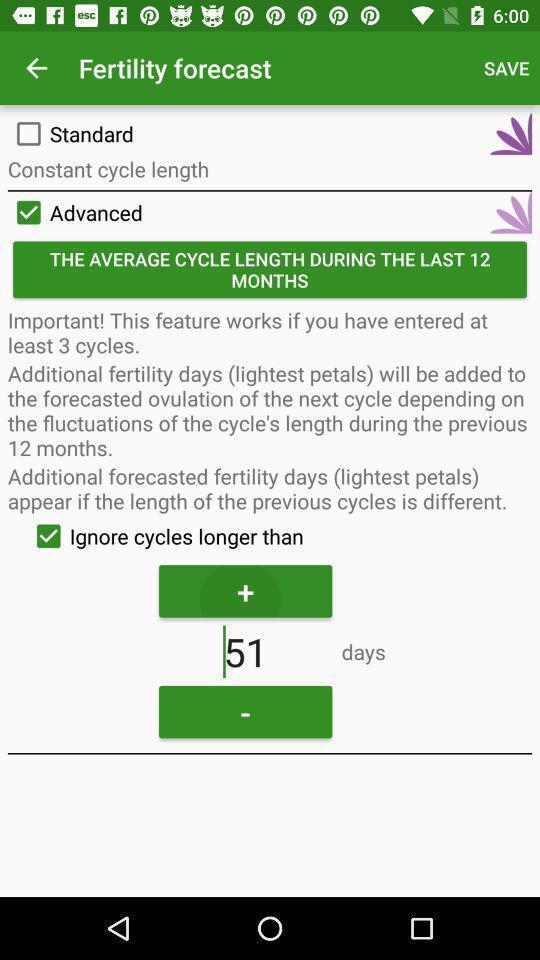Explain what's happening in this screen capture. Screen display fertility forecast information. 